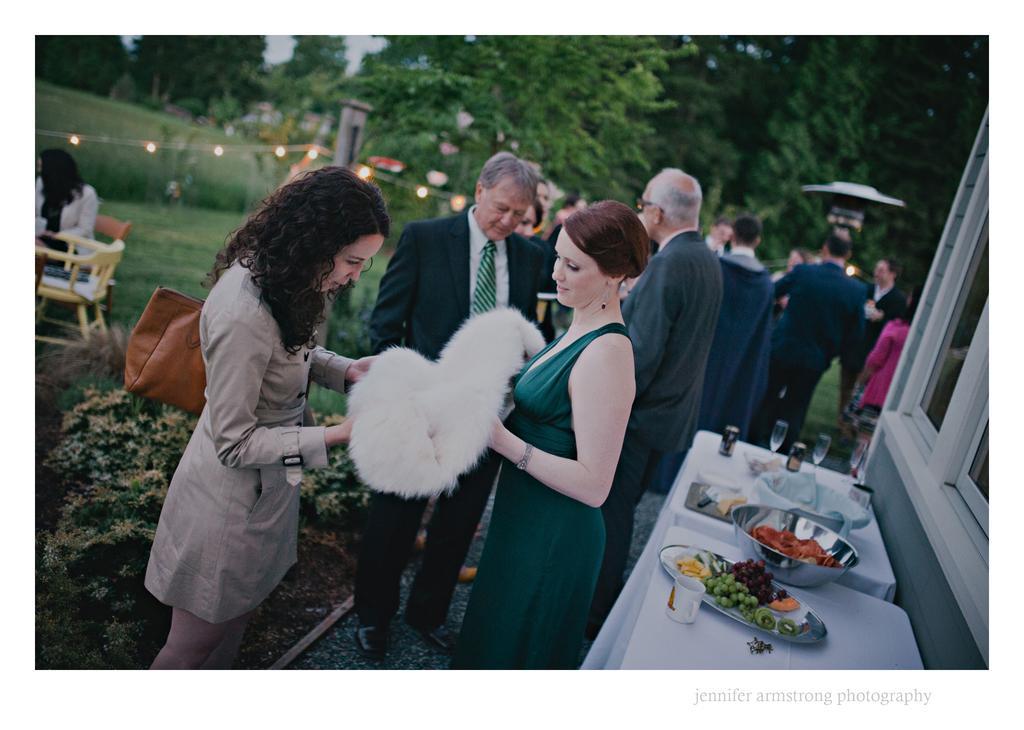Please provide a concise description of this image. In this image I can see there are group of persons visible and in the foreground I can see two woman holding a cloth and back side of them I can see a table , on the table I can see steel bowls and plates cups and on plates i can see food items and on the left side I can see chairs, a woman sitting on chair ,on the right side I can see a window. 